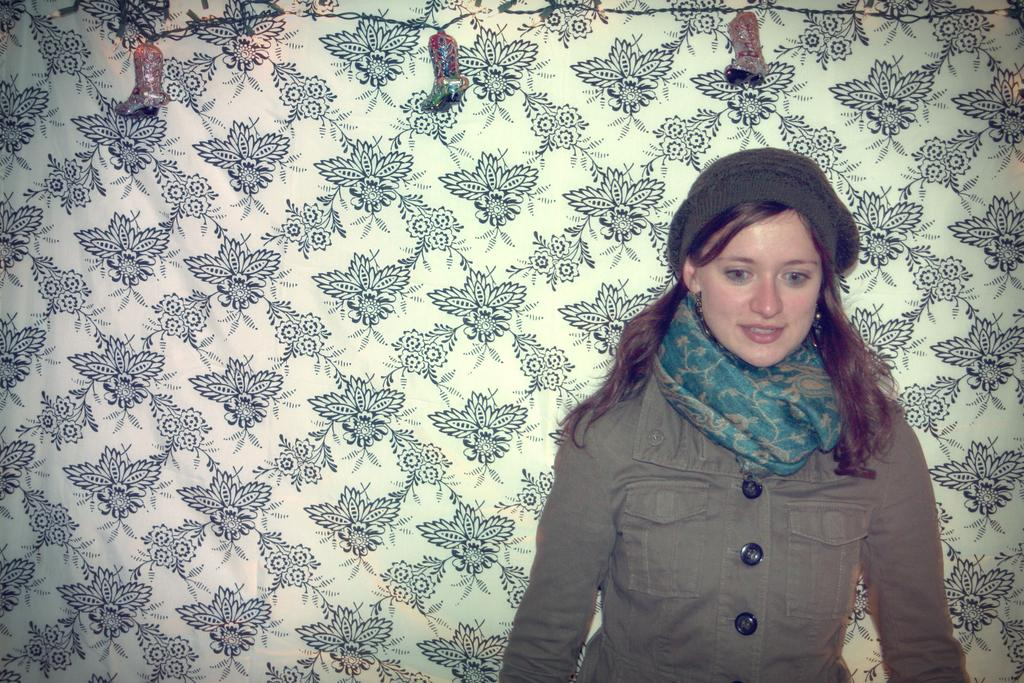Who is the main subject in the image? There is a woman in the image. What is the woman doing in the image? The woman is standing. What is the woman wearing around her neck? The woman is wearing a scarf. What type of clothing is the woman wearing? The woman is wearing clothes. What can be seen in the background of the image? There is a cloth with designs in the background of the image. What type of creature is standing next to the woman in the image? There is no creature standing next to the woman in the image. What type of jeans is the woman wearing in the image? The provided facts do not mention jeans; the woman is wearing clothes, but the specific type of clothing is not specified. 